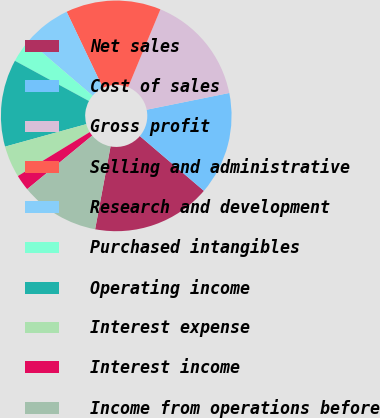<chart> <loc_0><loc_0><loc_500><loc_500><pie_chart><fcel>Net sales<fcel>Cost of sales<fcel>Gross profit<fcel>Selling and administrative<fcel>Research and development<fcel>Purchased intangibles<fcel>Operating income<fcel>Interest expense<fcel>Interest income<fcel>Income from operations before<nl><fcel>16.67%<fcel>14.44%<fcel>15.56%<fcel>13.33%<fcel>6.67%<fcel>3.33%<fcel>12.22%<fcel>4.44%<fcel>2.22%<fcel>11.11%<nl></chart> 